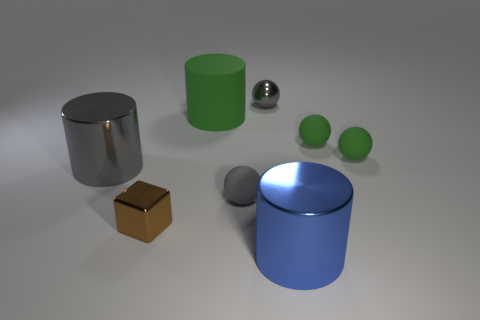What is the size of the cylinder that is the same color as the shiny ball?
Your answer should be compact. Large. There is a big shiny object on the left side of the large blue object; does it have the same shape as the green matte object that is left of the gray matte object?
Keep it short and to the point. Yes. The gray shiny thing that is the same shape as the small gray rubber thing is what size?
Give a very brief answer. Small. There is a sphere that is on the left side of the metal sphere; does it have the same color as the big metallic thing on the left side of the small metallic ball?
Offer a terse response. Yes. The cylinder in front of the shiny cylinder that is behind the object in front of the metal cube is made of what material?
Offer a terse response. Metal. Are there more gray things than rubber objects?
Ensure brevity in your answer.  No. Is there anything else that is the same color as the metallic sphere?
Offer a very short reply. Yes. What is the size of the gray ball that is made of the same material as the green cylinder?
Provide a succinct answer. Small. What material is the brown block?
Give a very brief answer. Metal. What number of other objects have the same size as the brown metallic thing?
Give a very brief answer. 4. 